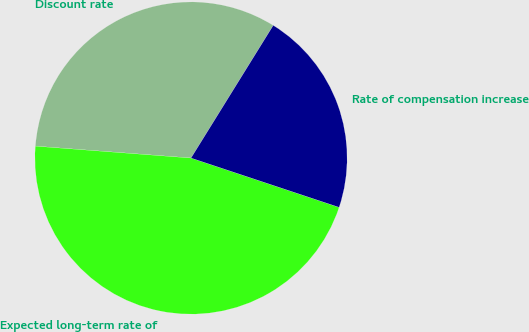Convert chart to OTSL. <chart><loc_0><loc_0><loc_500><loc_500><pie_chart><fcel>Discount rate<fcel>Expected long-term rate of<fcel>Rate of compensation increase<nl><fcel>32.62%<fcel>46.1%<fcel>21.28%<nl></chart> 